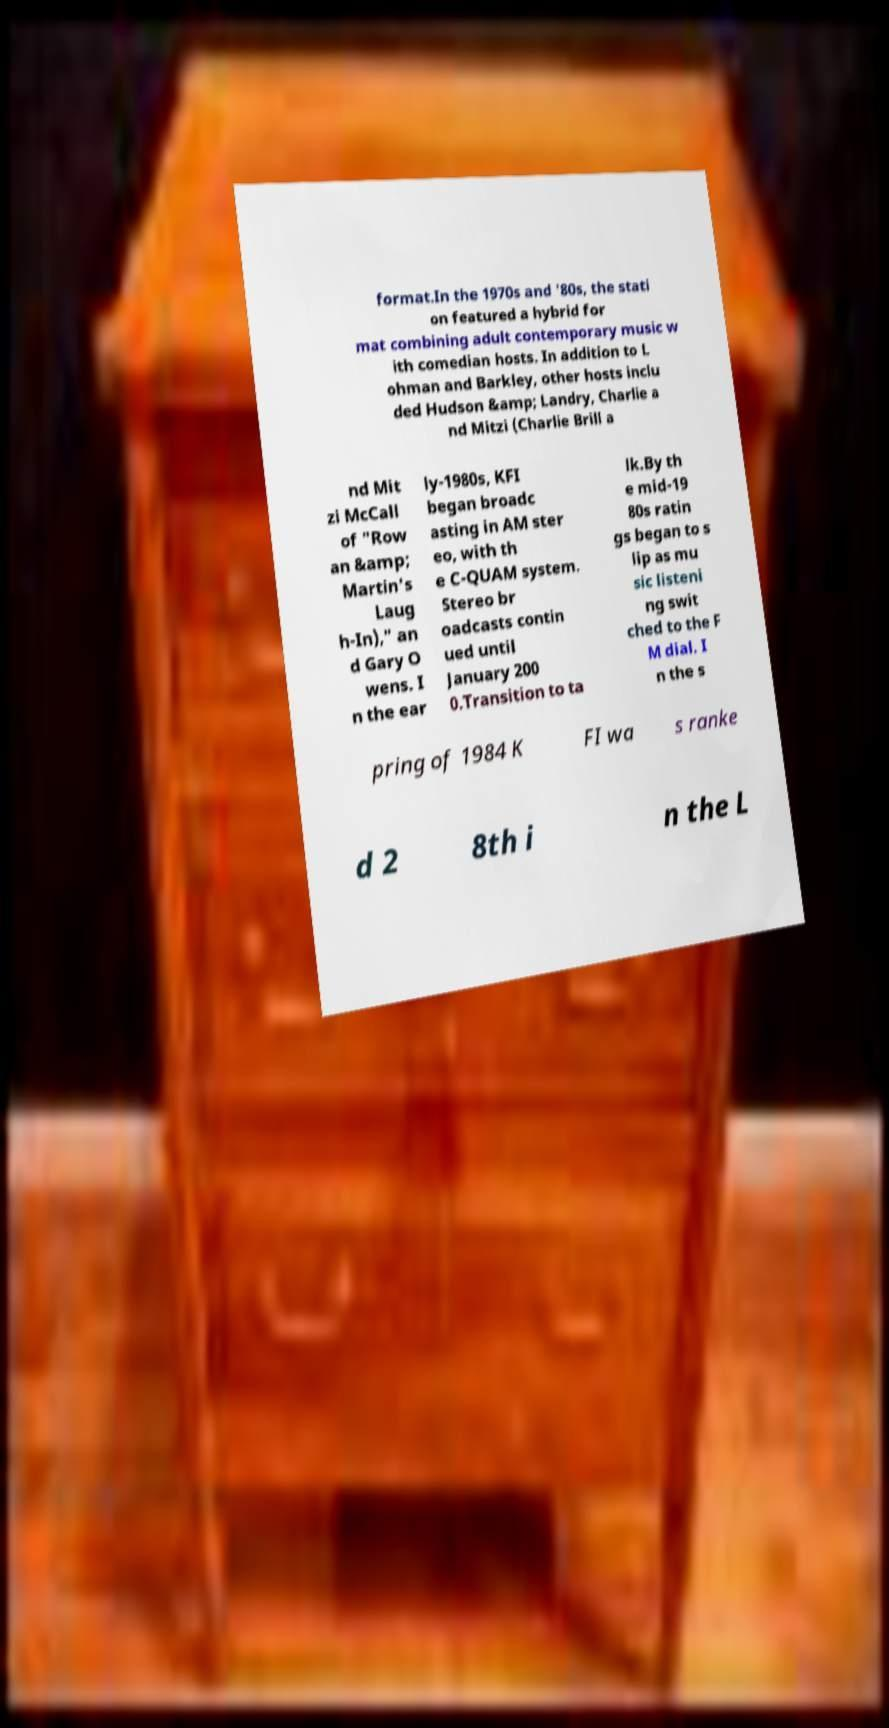What messages or text are displayed in this image? I need them in a readable, typed format. format.In the 1970s and '80s, the stati on featured a hybrid for mat combining adult contemporary music w ith comedian hosts. In addition to L ohman and Barkley, other hosts inclu ded Hudson &amp; Landry, Charlie a nd Mitzi (Charlie Brill a nd Mit zi McCall of "Row an &amp; Martin's Laug h-In)," an d Gary O wens. I n the ear ly-1980s, KFI began broadc asting in AM ster eo, with th e C-QUAM system. Stereo br oadcasts contin ued until January 200 0.Transition to ta lk.By th e mid-19 80s ratin gs began to s lip as mu sic listeni ng swit ched to the F M dial. I n the s pring of 1984 K FI wa s ranke d 2 8th i n the L 